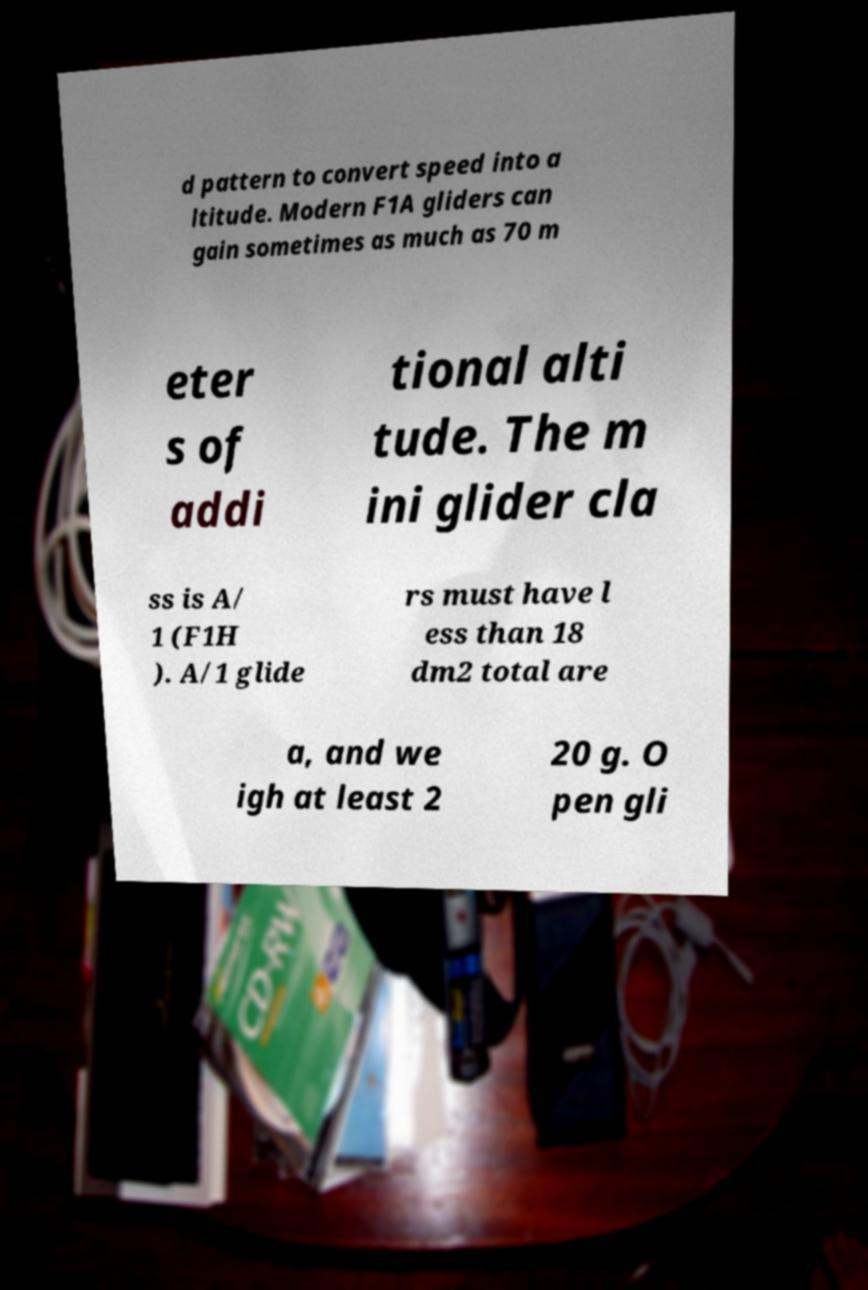For documentation purposes, I need the text within this image transcribed. Could you provide that? d pattern to convert speed into a ltitude. Modern F1A gliders can gain sometimes as much as 70 m eter s of addi tional alti tude. The m ini glider cla ss is A/ 1 (F1H ). A/1 glide rs must have l ess than 18 dm2 total are a, and we igh at least 2 20 g. O pen gli 